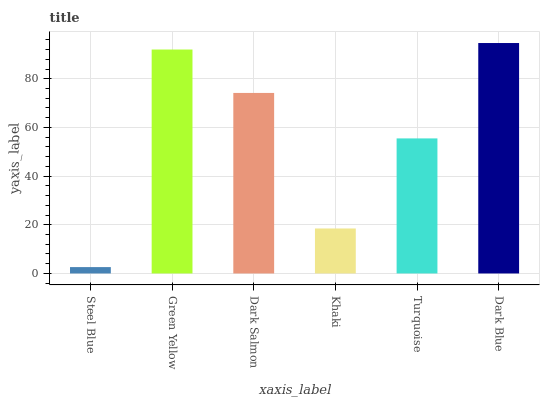Is Steel Blue the minimum?
Answer yes or no. Yes. Is Dark Blue the maximum?
Answer yes or no. Yes. Is Green Yellow the minimum?
Answer yes or no. No. Is Green Yellow the maximum?
Answer yes or no. No. Is Green Yellow greater than Steel Blue?
Answer yes or no. Yes. Is Steel Blue less than Green Yellow?
Answer yes or no. Yes. Is Steel Blue greater than Green Yellow?
Answer yes or no. No. Is Green Yellow less than Steel Blue?
Answer yes or no. No. Is Dark Salmon the high median?
Answer yes or no. Yes. Is Turquoise the low median?
Answer yes or no. Yes. Is Khaki the high median?
Answer yes or no. No. Is Dark Salmon the low median?
Answer yes or no. No. 